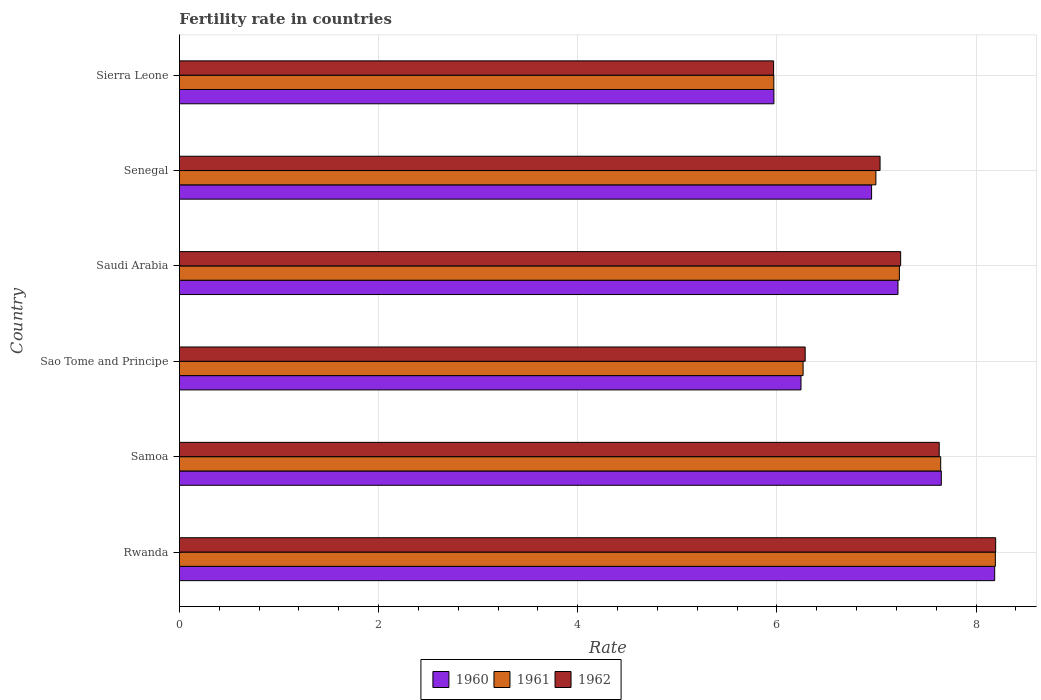How many different coloured bars are there?
Offer a very short reply. 3. How many groups of bars are there?
Provide a short and direct response. 6. Are the number of bars per tick equal to the number of legend labels?
Make the answer very short. Yes. Are the number of bars on each tick of the Y-axis equal?
Your response must be concise. Yes. How many bars are there on the 5th tick from the bottom?
Keep it short and to the point. 3. What is the label of the 5th group of bars from the top?
Offer a very short reply. Samoa. In how many cases, is the number of bars for a given country not equal to the number of legend labels?
Keep it short and to the point. 0. What is the fertility rate in 1961 in Sao Tome and Principe?
Make the answer very short. 6.26. Across all countries, what is the maximum fertility rate in 1960?
Ensure brevity in your answer.  8.19. Across all countries, what is the minimum fertility rate in 1960?
Provide a short and direct response. 5.97. In which country was the fertility rate in 1962 maximum?
Offer a very short reply. Rwanda. In which country was the fertility rate in 1960 minimum?
Give a very brief answer. Sierra Leone. What is the total fertility rate in 1962 in the graph?
Keep it short and to the point. 42.36. What is the difference between the fertility rate in 1961 in Rwanda and that in Samoa?
Offer a terse response. 0.55. What is the difference between the fertility rate in 1960 in Saudi Arabia and the fertility rate in 1962 in Sierra Leone?
Offer a very short reply. 1.25. What is the average fertility rate in 1962 per country?
Ensure brevity in your answer.  7.06. What is the difference between the fertility rate in 1961 and fertility rate in 1960 in Sao Tome and Principe?
Give a very brief answer. 0.02. In how many countries, is the fertility rate in 1962 greater than 0.8 ?
Keep it short and to the point. 6. What is the ratio of the fertility rate in 1961 in Rwanda to that in Saudi Arabia?
Your answer should be compact. 1.13. What is the difference between the highest and the second highest fertility rate in 1960?
Your answer should be compact. 0.54. What is the difference between the highest and the lowest fertility rate in 1960?
Offer a very short reply. 2.22. In how many countries, is the fertility rate in 1961 greater than the average fertility rate in 1961 taken over all countries?
Ensure brevity in your answer.  3. Is the sum of the fertility rate in 1960 in Samoa and Sao Tome and Principe greater than the maximum fertility rate in 1962 across all countries?
Give a very brief answer. Yes. What does the 3rd bar from the top in Samoa represents?
Provide a short and direct response. 1960. How many bars are there?
Your response must be concise. 18. Are all the bars in the graph horizontal?
Keep it short and to the point. Yes. How many countries are there in the graph?
Make the answer very short. 6. Are the values on the major ticks of X-axis written in scientific E-notation?
Provide a short and direct response. No. Where does the legend appear in the graph?
Offer a terse response. Bottom center. What is the title of the graph?
Offer a very short reply. Fertility rate in countries. What is the label or title of the X-axis?
Ensure brevity in your answer.  Rate. What is the label or title of the Y-axis?
Give a very brief answer. Country. What is the Rate of 1960 in Rwanda?
Your response must be concise. 8.19. What is the Rate of 1961 in Rwanda?
Offer a very short reply. 8.19. What is the Rate in 1962 in Rwanda?
Offer a very short reply. 8.2. What is the Rate of 1960 in Samoa?
Provide a short and direct response. 7.65. What is the Rate of 1961 in Samoa?
Provide a succinct answer. 7.64. What is the Rate of 1962 in Samoa?
Your response must be concise. 7.63. What is the Rate of 1960 in Sao Tome and Principe?
Your answer should be compact. 6.24. What is the Rate of 1961 in Sao Tome and Principe?
Offer a terse response. 6.26. What is the Rate of 1962 in Sao Tome and Principe?
Keep it short and to the point. 6.28. What is the Rate of 1960 in Saudi Arabia?
Offer a very short reply. 7.22. What is the Rate of 1961 in Saudi Arabia?
Give a very brief answer. 7.23. What is the Rate in 1962 in Saudi Arabia?
Ensure brevity in your answer.  7.24. What is the Rate of 1960 in Senegal?
Offer a very short reply. 6.95. What is the Rate of 1961 in Senegal?
Offer a terse response. 6.99. What is the Rate of 1962 in Senegal?
Offer a terse response. 7.04. What is the Rate of 1960 in Sierra Leone?
Give a very brief answer. 5.97. What is the Rate of 1961 in Sierra Leone?
Your answer should be compact. 5.97. What is the Rate in 1962 in Sierra Leone?
Your answer should be compact. 5.97. Across all countries, what is the maximum Rate of 1960?
Your answer should be very brief. 8.19. Across all countries, what is the maximum Rate of 1961?
Provide a succinct answer. 8.19. Across all countries, what is the maximum Rate of 1962?
Your response must be concise. 8.2. Across all countries, what is the minimum Rate in 1960?
Keep it short and to the point. 5.97. Across all countries, what is the minimum Rate of 1961?
Offer a very short reply. 5.97. Across all countries, what is the minimum Rate of 1962?
Offer a terse response. 5.97. What is the total Rate in 1960 in the graph?
Ensure brevity in your answer.  42.22. What is the total Rate of 1961 in the graph?
Ensure brevity in your answer.  42.3. What is the total Rate in 1962 in the graph?
Make the answer very short. 42.36. What is the difference between the Rate in 1960 in Rwanda and that in Samoa?
Give a very brief answer. 0.54. What is the difference between the Rate of 1961 in Rwanda and that in Samoa?
Provide a short and direct response. 0.55. What is the difference between the Rate in 1962 in Rwanda and that in Samoa?
Provide a succinct answer. 0.57. What is the difference between the Rate of 1960 in Rwanda and that in Sao Tome and Principe?
Offer a terse response. 1.95. What is the difference between the Rate in 1961 in Rwanda and that in Sao Tome and Principe?
Ensure brevity in your answer.  1.93. What is the difference between the Rate of 1962 in Rwanda and that in Sao Tome and Principe?
Provide a succinct answer. 1.91. What is the difference between the Rate of 1960 in Rwanda and that in Saudi Arabia?
Your answer should be very brief. 0.97. What is the difference between the Rate of 1962 in Rwanda and that in Saudi Arabia?
Provide a short and direct response. 0.95. What is the difference between the Rate in 1960 in Rwanda and that in Senegal?
Provide a short and direct response. 1.24. What is the difference between the Rate in 1961 in Rwanda and that in Senegal?
Keep it short and to the point. 1.2. What is the difference between the Rate in 1962 in Rwanda and that in Senegal?
Your response must be concise. 1.16. What is the difference between the Rate of 1960 in Rwanda and that in Sierra Leone?
Make the answer very short. 2.22. What is the difference between the Rate of 1961 in Rwanda and that in Sierra Leone?
Your answer should be compact. 2.23. What is the difference between the Rate in 1962 in Rwanda and that in Sierra Leone?
Keep it short and to the point. 2.23. What is the difference between the Rate of 1960 in Samoa and that in Sao Tome and Principe?
Offer a very short reply. 1.41. What is the difference between the Rate of 1961 in Samoa and that in Sao Tome and Principe?
Keep it short and to the point. 1.38. What is the difference between the Rate in 1962 in Samoa and that in Sao Tome and Principe?
Your answer should be compact. 1.35. What is the difference between the Rate of 1960 in Samoa and that in Saudi Arabia?
Keep it short and to the point. 0.43. What is the difference between the Rate in 1961 in Samoa and that in Saudi Arabia?
Offer a very short reply. 0.41. What is the difference between the Rate of 1962 in Samoa and that in Saudi Arabia?
Provide a succinct answer. 0.39. What is the difference between the Rate of 1960 in Samoa and that in Senegal?
Provide a succinct answer. 0.7. What is the difference between the Rate in 1961 in Samoa and that in Senegal?
Provide a succinct answer. 0.65. What is the difference between the Rate of 1962 in Samoa and that in Senegal?
Your answer should be very brief. 0.59. What is the difference between the Rate in 1960 in Samoa and that in Sierra Leone?
Ensure brevity in your answer.  1.68. What is the difference between the Rate of 1961 in Samoa and that in Sierra Leone?
Offer a terse response. 1.68. What is the difference between the Rate of 1962 in Samoa and that in Sierra Leone?
Make the answer very short. 1.66. What is the difference between the Rate in 1960 in Sao Tome and Principe and that in Saudi Arabia?
Keep it short and to the point. -0.97. What is the difference between the Rate of 1961 in Sao Tome and Principe and that in Saudi Arabia?
Offer a very short reply. -0.97. What is the difference between the Rate in 1962 in Sao Tome and Principe and that in Saudi Arabia?
Ensure brevity in your answer.  -0.96. What is the difference between the Rate of 1960 in Sao Tome and Principe and that in Senegal?
Give a very brief answer. -0.71. What is the difference between the Rate of 1961 in Sao Tome and Principe and that in Senegal?
Provide a succinct answer. -0.73. What is the difference between the Rate in 1962 in Sao Tome and Principe and that in Senegal?
Keep it short and to the point. -0.75. What is the difference between the Rate in 1960 in Sao Tome and Principe and that in Sierra Leone?
Your answer should be very brief. 0.27. What is the difference between the Rate of 1961 in Sao Tome and Principe and that in Sierra Leone?
Provide a short and direct response. 0.29. What is the difference between the Rate of 1962 in Sao Tome and Principe and that in Sierra Leone?
Offer a very short reply. 0.32. What is the difference between the Rate of 1960 in Saudi Arabia and that in Senegal?
Provide a short and direct response. 0.27. What is the difference between the Rate in 1961 in Saudi Arabia and that in Senegal?
Provide a short and direct response. 0.24. What is the difference between the Rate in 1962 in Saudi Arabia and that in Senegal?
Your response must be concise. 0.21. What is the difference between the Rate in 1960 in Saudi Arabia and that in Sierra Leone?
Make the answer very short. 1.25. What is the difference between the Rate of 1961 in Saudi Arabia and that in Sierra Leone?
Give a very brief answer. 1.26. What is the difference between the Rate of 1962 in Saudi Arabia and that in Sierra Leone?
Give a very brief answer. 1.28. What is the difference between the Rate of 1960 in Senegal and that in Sierra Leone?
Your response must be concise. 0.98. What is the difference between the Rate in 1962 in Senegal and that in Sierra Leone?
Make the answer very short. 1.07. What is the difference between the Rate of 1960 in Rwanda and the Rate of 1961 in Samoa?
Keep it short and to the point. 0.54. What is the difference between the Rate in 1960 in Rwanda and the Rate in 1962 in Samoa?
Make the answer very short. 0.56. What is the difference between the Rate in 1961 in Rwanda and the Rate in 1962 in Samoa?
Provide a succinct answer. 0.56. What is the difference between the Rate of 1960 in Rwanda and the Rate of 1961 in Sao Tome and Principe?
Your response must be concise. 1.92. What is the difference between the Rate in 1960 in Rwanda and the Rate in 1962 in Sao Tome and Principe?
Ensure brevity in your answer.  1.9. What is the difference between the Rate in 1961 in Rwanda and the Rate in 1962 in Sao Tome and Principe?
Give a very brief answer. 1.91. What is the difference between the Rate in 1960 in Rwanda and the Rate in 1961 in Saudi Arabia?
Ensure brevity in your answer.  0.96. What is the difference between the Rate of 1960 in Rwanda and the Rate of 1962 in Saudi Arabia?
Your answer should be compact. 0.94. What is the difference between the Rate of 1961 in Rwanda and the Rate of 1962 in Saudi Arabia?
Offer a terse response. 0.95. What is the difference between the Rate of 1960 in Rwanda and the Rate of 1961 in Senegal?
Your answer should be very brief. 1.19. What is the difference between the Rate in 1960 in Rwanda and the Rate in 1962 in Senegal?
Provide a short and direct response. 1.15. What is the difference between the Rate of 1961 in Rwanda and the Rate of 1962 in Senegal?
Keep it short and to the point. 1.16. What is the difference between the Rate in 1960 in Rwanda and the Rate in 1961 in Sierra Leone?
Make the answer very short. 2.22. What is the difference between the Rate in 1960 in Rwanda and the Rate in 1962 in Sierra Leone?
Offer a very short reply. 2.22. What is the difference between the Rate in 1961 in Rwanda and the Rate in 1962 in Sierra Leone?
Provide a succinct answer. 2.23. What is the difference between the Rate of 1960 in Samoa and the Rate of 1961 in Sao Tome and Principe?
Make the answer very short. 1.39. What is the difference between the Rate in 1960 in Samoa and the Rate in 1962 in Sao Tome and Principe?
Your answer should be compact. 1.37. What is the difference between the Rate in 1961 in Samoa and the Rate in 1962 in Sao Tome and Principe?
Ensure brevity in your answer.  1.36. What is the difference between the Rate of 1960 in Samoa and the Rate of 1961 in Saudi Arabia?
Your response must be concise. 0.42. What is the difference between the Rate of 1960 in Samoa and the Rate of 1962 in Saudi Arabia?
Keep it short and to the point. 0.41. What is the difference between the Rate of 1961 in Samoa and the Rate of 1962 in Saudi Arabia?
Provide a short and direct response. 0.4. What is the difference between the Rate in 1960 in Samoa and the Rate in 1961 in Senegal?
Your answer should be very brief. 0.66. What is the difference between the Rate of 1960 in Samoa and the Rate of 1962 in Senegal?
Offer a very short reply. 0.61. What is the difference between the Rate of 1961 in Samoa and the Rate of 1962 in Senegal?
Make the answer very short. 0.61. What is the difference between the Rate of 1960 in Samoa and the Rate of 1961 in Sierra Leone?
Provide a succinct answer. 1.68. What is the difference between the Rate of 1960 in Samoa and the Rate of 1962 in Sierra Leone?
Your answer should be compact. 1.68. What is the difference between the Rate in 1961 in Samoa and the Rate in 1962 in Sierra Leone?
Provide a short and direct response. 1.68. What is the difference between the Rate of 1960 in Sao Tome and Principe and the Rate of 1961 in Saudi Arabia?
Ensure brevity in your answer.  -0.99. What is the difference between the Rate of 1960 in Sao Tome and Principe and the Rate of 1962 in Saudi Arabia?
Offer a very short reply. -1. What is the difference between the Rate of 1961 in Sao Tome and Principe and the Rate of 1962 in Saudi Arabia?
Your answer should be compact. -0.98. What is the difference between the Rate in 1960 in Sao Tome and Principe and the Rate in 1961 in Senegal?
Keep it short and to the point. -0.75. What is the difference between the Rate in 1960 in Sao Tome and Principe and the Rate in 1962 in Senegal?
Offer a terse response. -0.79. What is the difference between the Rate of 1961 in Sao Tome and Principe and the Rate of 1962 in Senegal?
Your answer should be compact. -0.77. What is the difference between the Rate of 1960 in Sao Tome and Principe and the Rate of 1961 in Sierra Leone?
Keep it short and to the point. 0.27. What is the difference between the Rate in 1960 in Sao Tome and Principe and the Rate in 1962 in Sierra Leone?
Provide a succinct answer. 0.28. What is the difference between the Rate of 1961 in Sao Tome and Principe and the Rate of 1962 in Sierra Leone?
Ensure brevity in your answer.  0.3. What is the difference between the Rate in 1960 in Saudi Arabia and the Rate in 1961 in Senegal?
Provide a succinct answer. 0.22. What is the difference between the Rate of 1960 in Saudi Arabia and the Rate of 1962 in Senegal?
Provide a succinct answer. 0.18. What is the difference between the Rate in 1961 in Saudi Arabia and the Rate in 1962 in Senegal?
Your response must be concise. 0.19. What is the difference between the Rate in 1960 in Saudi Arabia and the Rate in 1961 in Sierra Leone?
Your answer should be very brief. 1.25. What is the difference between the Rate of 1960 in Saudi Arabia and the Rate of 1962 in Sierra Leone?
Ensure brevity in your answer.  1.25. What is the difference between the Rate of 1961 in Saudi Arabia and the Rate of 1962 in Sierra Leone?
Ensure brevity in your answer.  1.26. What is the difference between the Rate in 1960 in Senegal and the Rate in 1961 in Sierra Leone?
Offer a terse response. 0.98. What is the difference between the Rate in 1960 in Senegal and the Rate in 1962 in Sierra Leone?
Make the answer very short. 0.98. What is the difference between the Rate of 1961 in Senegal and the Rate of 1962 in Sierra Leone?
Your answer should be compact. 1.03. What is the average Rate in 1960 per country?
Your response must be concise. 7.04. What is the average Rate in 1961 per country?
Make the answer very short. 7.05. What is the average Rate in 1962 per country?
Ensure brevity in your answer.  7.06. What is the difference between the Rate of 1960 and Rate of 1961 in Rwanda?
Your answer should be compact. -0.01. What is the difference between the Rate of 1960 and Rate of 1962 in Rwanda?
Your answer should be compact. -0.01. What is the difference between the Rate in 1961 and Rate in 1962 in Rwanda?
Provide a short and direct response. -0. What is the difference between the Rate in 1960 and Rate in 1961 in Samoa?
Keep it short and to the point. 0.01. What is the difference between the Rate of 1960 and Rate of 1962 in Samoa?
Offer a terse response. 0.02. What is the difference between the Rate in 1961 and Rate in 1962 in Samoa?
Give a very brief answer. 0.01. What is the difference between the Rate of 1960 and Rate of 1961 in Sao Tome and Principe?
Keep it short and to the point. -0.02. What is the difference between the Rate in 1960 and Rate in 1962 in Sao Tome and Principe?
Offer a terse response. -0.04. What is the difference between the Rate in 1961 and Rate in 1962 in Sao Tome and Principe?
Offer a very short reply. -0.02. What is the difference between the Rate in 1960 and Rate in 1961 in Saudi Arabia?
Make the answer very short. -0.01. What is the difference between the Rate of 1960 and Rate of 1962 in Saudi Arabia?
Keep it short and to the point. -0.03. What is the difference between the Rate of 1961 and Rate of 1962 in Saudi Arabia?
Ensure brevity in your answer.  -0.01. What is the difference between the Rate in 1960 and Rate in 1961 in Senegal?
Ensure brevity in your answer.  -0.04. What is the difference between the Rate in 1960 and Rate in 1962 in Senegal?
Offer a terse response. -0.09. What is the difference between the Rate of 1961 and Rate of 1962 in Senegal?
Provide a short and direct response. -0.04. What is the difference between the Rate in 1960 and Rate in 1961 in Sierra Leone?
Provide a short and direct response. 0. What is the difference between the Rate of 1960 and Rate of 1962 in Sierra Leone?
Provide a succinct answer. 0. What is the difference between the Rate in 1961 and Rate in 1962 in Sierra Leone?
Provide a short and direct response. 0. What is the ratio of the Rate in 1960 in Rwanda to that in Samoa?
Give a very brief answer. 1.07. What is the ratio of the Rate in 1961 in Rwanda to that in Samoa?
Offer a terse response. 1.07. What is the ratio of the Rate of 1962 in Rwanda to that in Samoa?
Ensure brevity in your answer.  1.07. What is the ratio of the Rate in 1960 in Rwanda to that in Sao Tome and Principe?
Your answer should be very brief. 1.31. What is the ratio of the Rate of 1961 in Rwanda to that in Sao Tome and Principe?
Your answer should be very brief. 1.31. What is the ratio of the Rate of 1962 in Rwanda to that in Sao Tome and Principe?
Make the answer very short. 1.3. What is the ratio of the Rate in 1960 in Rwanda to that in Saudi Arabia?
Give a very brief answer. 1.13. What is the ratio of the Rate in 1961 in Rwanda to that in Saudi Arabia?
Ensure brevity in your answer.  1.13. What is the ratio of the Rate in 1962 in Rwanda to that in Saudi Arabia?
Ensure brevity in your answer.  1.13. What is the ratio of the Rate of 1960 in Rwanda to that in Senegal?
Ensure brevity in your answer.  1.18. What is the ratio of the Rate of 1961 in Rwanda to that in Senegal?
Give a very brief answer. 1.17. What is the ratio of the Rate in 1962 in Rwanda to that in Senegal?
Ensure brevity in your answer.  1.17. What is the ratio of the Rate in 1960 in Rwanda to that in Sierra Leone?
Your response must be concise. 1.37. What is the ratio of the Rate in 1961 in Rwanda to that in Sierra Leone?
Your answer should be very brief. 1.37. What is the ratio of the Rate of 1962 in Rwanda to that in Sierra Leone?
Your answer should be very brief. 1.37. What is the ratio of the Rate of 1960 in Samoa to that in Sao Tome and Principe?
Provide a succinct answer. 1.23. What is the ratio of the Rate in 1961 in Samoa to that in Sao Tome and Principe?
Offer a terse response. 1.22. What is the ratio of the Rate of 1962 in Samoa to that in Sao Tome and Principe?
Keep it short and to the point. 1.21. What is the ratio of the Rate of 1960 in Samoa to that in Saudi Arabia?
Provide a succinct answer. 1.06. What is the ratio of the Rate of 1961 in Samoa to that in Saudi Arabia?
Offer a very short reply. 1.06. What is the ratio of the Rate of 1962 in Samoa to that in Saudi Arabia?
Keep it short and to the point. 1.05. What is the ratio of the Rate of 1960 in Samoa to that in Senegal?
Keep it short and to the point. 1.1. What is the ratio of the Rate of 1961 in Samoa to that in Senegal?
Give a very brief answer. 1.09. What is the ratio of the Rate of 1962 in Samoa to that in Senegal?
Make the answer very short. 1.08. What is the ratio of the Rate of 1960 in Samoa to that in Sierra Leone?
Provide a short and direct response. 1.28. What is the ratio of the Rate of 1961 in Samoa to that in Sierra Leone?
Keep it short and to the point. 1.28. What is the ratio of the Rate in 1962 in Samoa to that in Sierra Leone?
Your answer should be compact. 1.28. What is the ratio of the Rate in 1960 in Sao Tome and Principe to that in Saudi Arabia?
Provide a short and direct response. 0.86. What is the ratio of the Rate in 1961 in Sao Tome and Principe to that in Saudi Arabia?
Ensure brevity in your answer.  0.87. What is the ratio of the Rate of 1962 in Sao Tome and Principe to that in Saudi Arabia?
Offer a terse response. 0.87. What is the ratio of the Rate of 1960 in Sao Tome and Principe to that in Senegal?
Your answer should be very brief. 0.9. What is the ratio of the Rate in 1961 in Sao Tome and Principe to that in Senegal?
Offer a very short reply. 0.9. What is the ratio of the Rate of 1962 in Sao Tome and Principe to that in Senegal?
Your response must be concise. 0.89. What is the ratio of the Rate in 1960 in Sao Tome and Principe to that in Sierra Leone?
Keep it short and to the point. 1.05. What is the ratio of the Rate of 1961 in Sao Tome and Principe to that in Sierra Leone?
Give a very brief answer. 1.05. What is the ratio of the Rate of 1962 in Sao Tome and Principe to that in Sierra Leone?
Provide a succinct answer. 1.05. What is the ratio of the Rate of 1960 in Saudi Arabia to that in Senegal?
Your answer should be compact. 1.04. What is the ratio of the Rate of 1961 in Saudi Arabia to that in Senegal?
Your answer should be very brief. 1.03. What is the ratio of the Rate of 1962 in Saudi Arabia to that in Senegal?
Give a very brief answer. 1.03. What is the ratio of the Rate of 1960 in Saudi Arabia to that in Sierra Leone?
Ensure brevity in your answer.  1.21. What is the ratio of the Rate of 1961 in Saudi Arabia to that in Sierra Leone?
Provide a short and direct response. 1.21. What is the ratio of the Rate in 1962 in Saudi Arabia to that in Sierra Leone?
Your response must be concise. 1.21. What is the ratio of the Rate of 1960 in Senegal to that in Sierra Leone?
Provide a succinct answer. 1.16. What is the ratio of the Rate of 1961 in Senegal to that in Sierra Leone?
Provide a short and direct response. 1.17. What is the ratio of the Rate of 1962 in Senegal to that in Sierra Leone?
Your response must be concise. 1.18. What is the difference between the highest and the second highest Rate of 1960?
Offer a very short reply. 0.54. What is the difference between the highest and the second highest Rate in 1961?
Your answer should be compact. 0.55. What is the difference between the highest and the second highest Rate in 1962?
Offer a terse response. 0.57. What is the difference between the highest and the lowest Rate of 1960?
Give a very brief answer. 2.22. What is the difference between the highest and the lowest Rate in 1961?
Keep it short and to the point. 2.23. What is the difference between the highest and the lowest Rate in 1962?
Offer a very short reply. 2.23. 